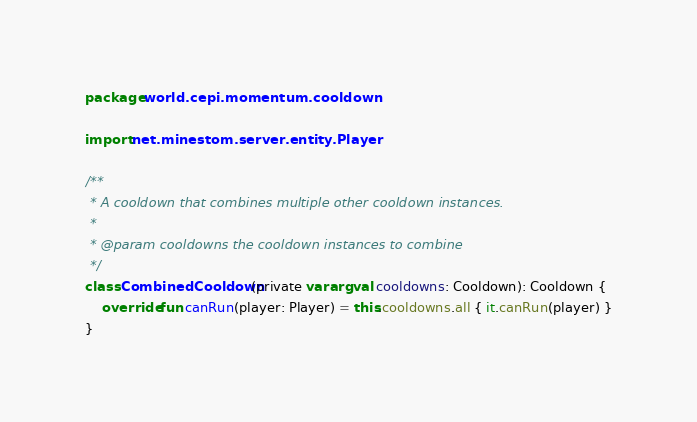<code> <loc_0><loc_0><loc_500><loc_500><_Kotlin_>package world.cepi.momentum.cooldown

import net.minestom.server.entity.Player

/**
 * A cooldown that combines multiple other cooldown instances.
 *
 * @param cooldowns the cooldown instances to combine
 */
class CombinedCooldown(private vararg val cooldowns: Cooldown): Cooldown {
    override fun canRun(player: Player) = this.cooldowns.all { it.canRun(player) }
}</code> 